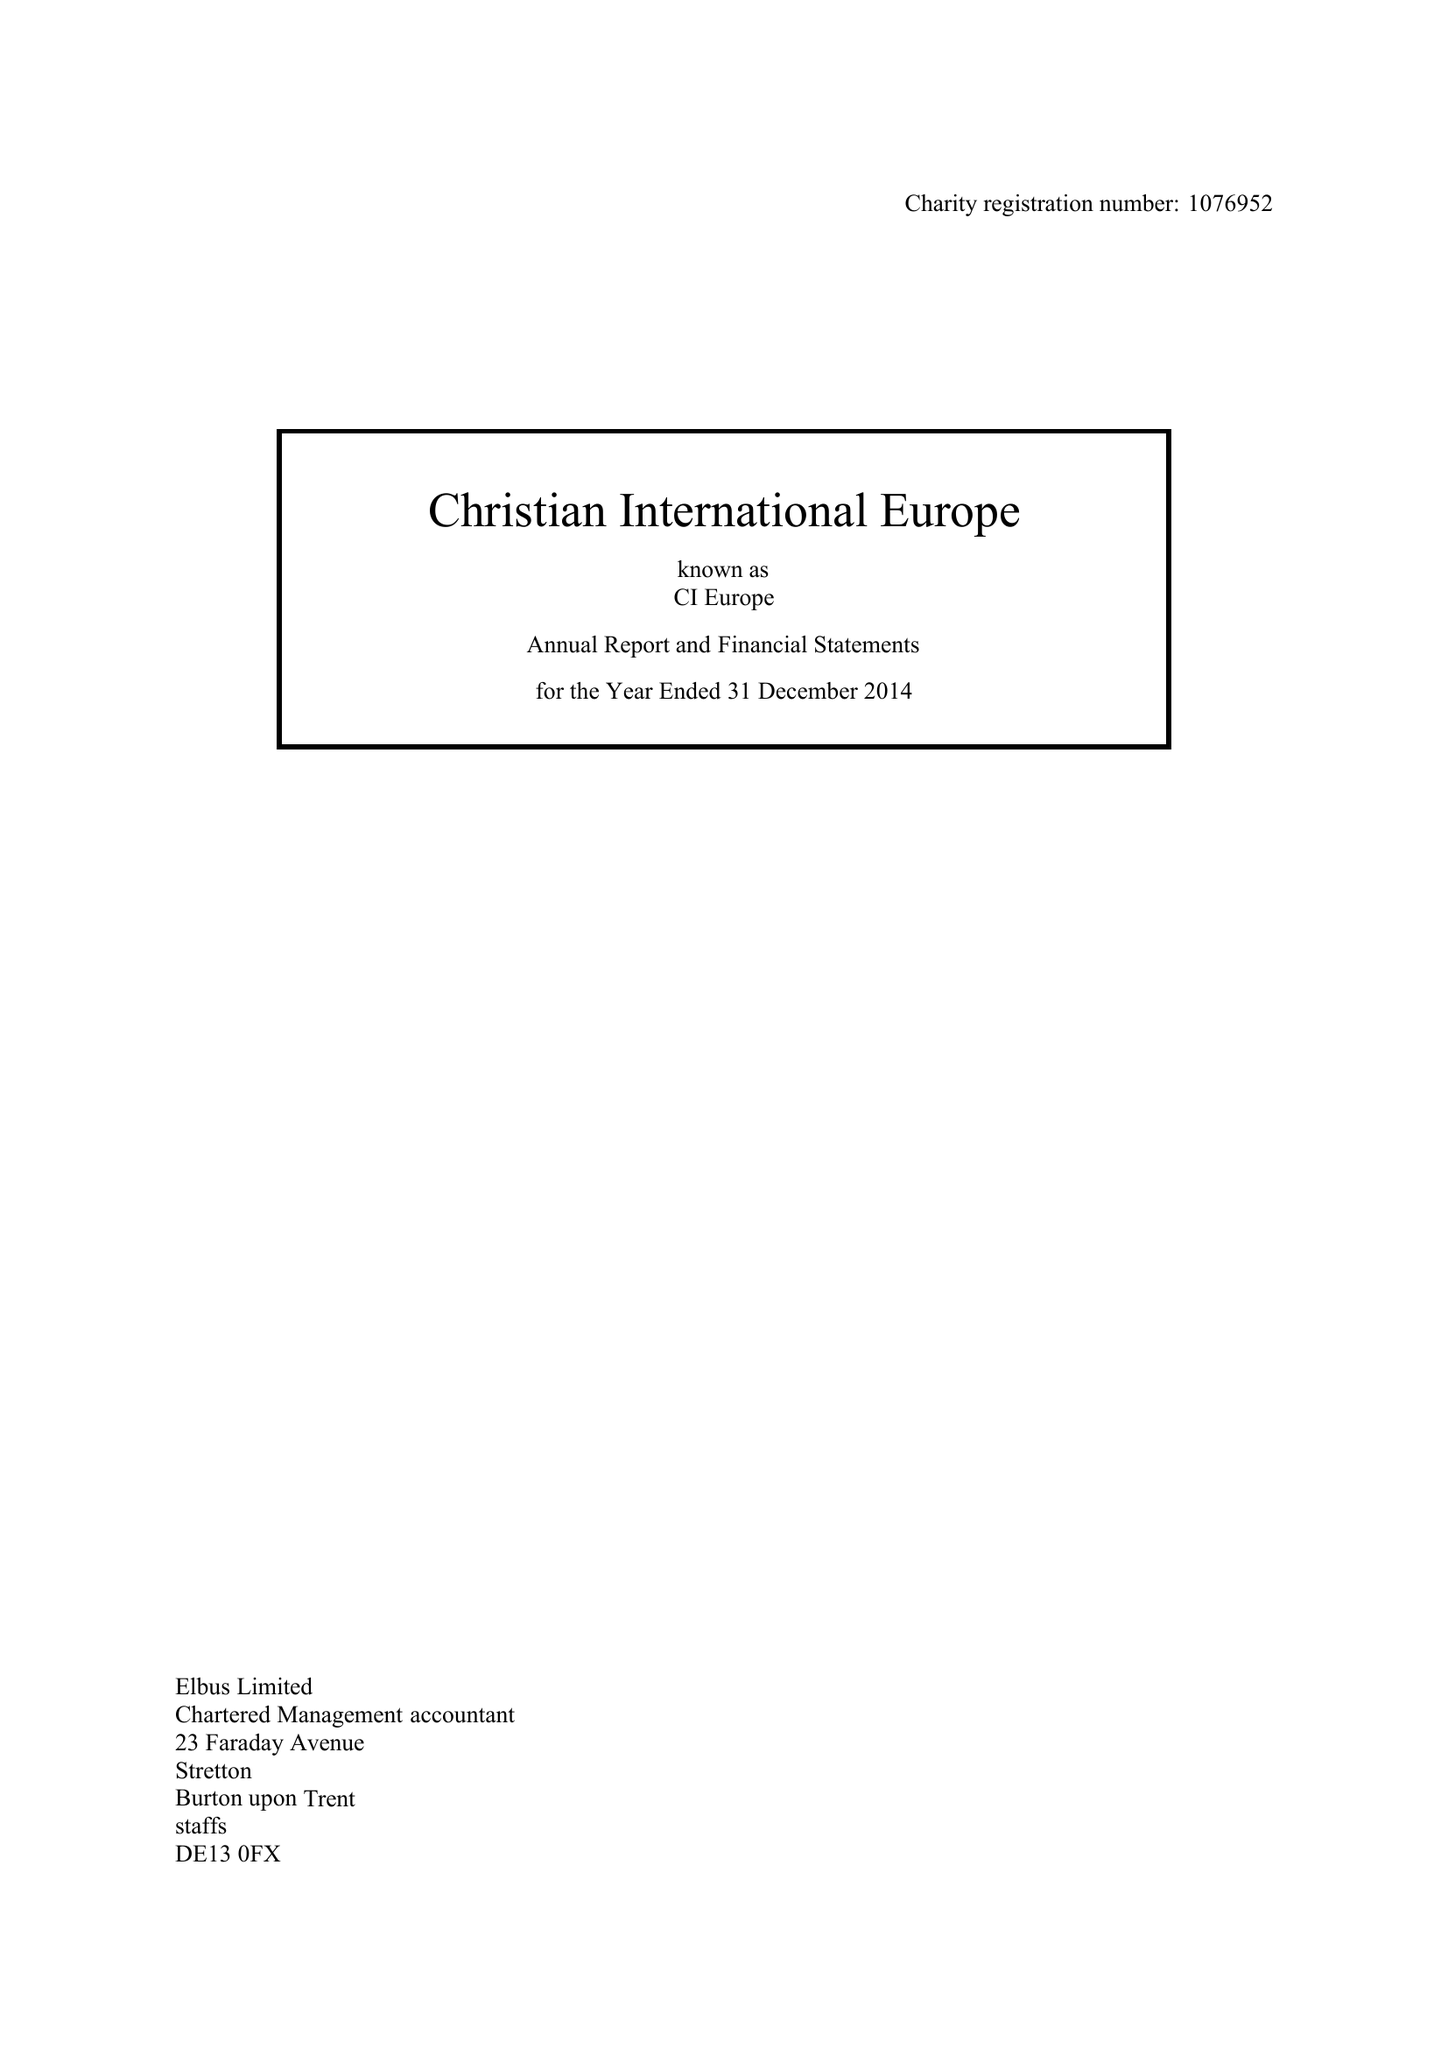What is the value for the address__post_town?
Answer the question using a single word or phrase. WINDSOR 